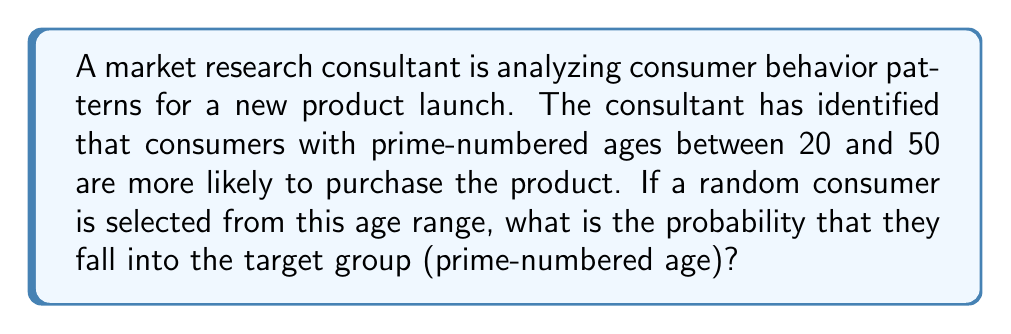Could you help me with this problem? To solve this problem, we need to follow these steps:

1. Identify the prime numbers between 20 and 50.
2. Count the total numbers in the range 20 to 50.
3. Calculate the probability using the formula: $P(\text{prime age}) = \frac{\text{number of prime ages}}{\text{total number of ages}}$

Step 1: Prime numbers between 20 and 50
The prime numbers in this range are: 23, 29, 31, 37, 41, 43, 47

Step 2: Count of total numbers
The range includes all integers from 20 to 50, inclusive. 
Total count = 50 - 20 + 1 = 31

Step 3: Calculate the probability
$$P(\text{prime age}) = \frac{\text{number of prime ages}}{\text{total number of ages}} = \frac{7}{31}$$

This fraction cannot be simplified further as both 7 and 31 are prime numbers.
Answer: The probability that a randomly selected consumer between the ages of 20 and 50 has a prime-numbered age is $\frac{7}{31}$ or approximately 0.2258 (22.58%). 